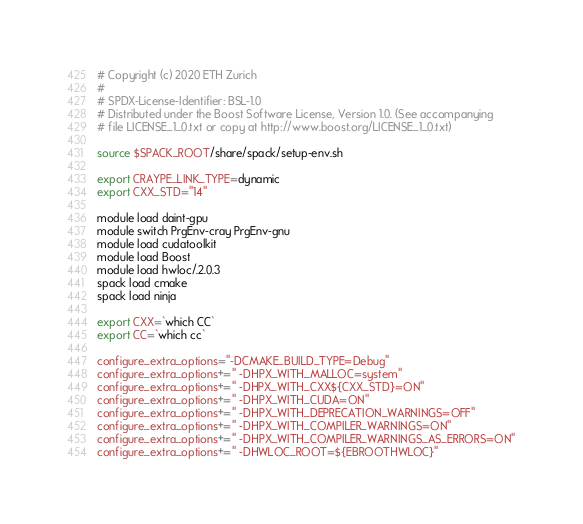<code> <loc_0><loc_0><loc_500><loc_500><_Bash_># Copyright (c) 2020 ETH Zurich
#
# SPDX-License-Identifier: BSL-1.0
# Distributed under the Boost Software License, Version 1.0. (See accompanying
# file LICENSE_1_0.txt or copy at http://www.boost.org/LICENSE_1_0.txt)

source $SPACK_ROOT/share/spack/setup-env.sh

export CRAYPE_LINK_TYPE=dynamic
export CXX_STD="14"

module load daint-gpu
module switch PrgEnv-cray PrgEnv-gnu
module load cudatoolkit
module load Boost
module load hwloc/.2.0.3
spack load cmake
spack load ninja

export CXX=`which CC`
export CC=`which cc`

configure_extra_options="-DCMAKE_BUILD_TYPE=Debug"
configure_extra_options+=" -DHPX_WITH_MALLOC=system"
configure_extra_options+=" -DHPX_WITH_CXX${CXX_STD}=ON"
configure_extra_options+=" -DHPX_WITH_CUDA=ON"
configure_extra_options+=" -DHPX_WITH_DEPRECATION_WARNINGS=OFF"
configure_extra_options+=" -DHPX_WITH_COMPILER_WARNINGS=ON"
configure_extra_options+=" -DHPX_WITH_COMPILER_WARNINGS_AS_ERRORS=ON"
configure_extra_options+=" -DHWLOC_ROOT=${EBROOTHWLOC}"
</code> 